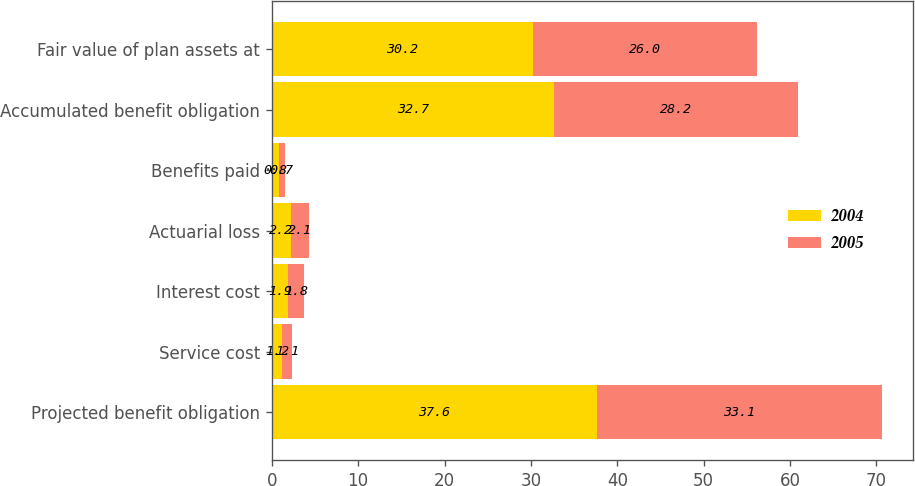Convert chart to OTSL. <chart><loc_0><loc_0><loc_500><loc_500><stacked_bar_chart><ecel><fcel>Projected benefit obligation<fcel>Service cost<fcel>Interest cost<fcel>Actuarial loss<fcel>Benefits paid<fcel>Accumulated benefit obligation<fcel>Fair value of plan assets at<nl><fcel>2004<fcel>37.6<fcel>1.2<fcel>1.9<fcel>2.2<fcel>0.8<fcel>32.7<fcel>30.2<nl><fcel>2005<fcel>33.1<fcel>1.1<fcel>1.8<fcel>2.1<fcel>0.7<fcel>28.2<fcel>26<nl></chart> 